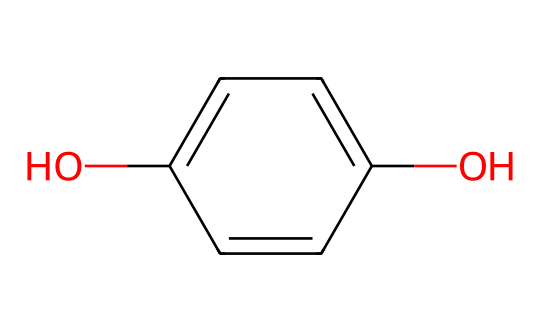What is the name of this chemical? The SMILES representation corresponds to the structure of hydroquinone, which is a dihydroxybenzene derivative known for its use in skin-lightening products.
Answer: hydroquinone How many hydroxyl (–OH) groups are present in this molecule? The structure has two hydroxyl groups (–OH) attached to the benzene ring, indicated by the two 'O' atoms in the SMILES representation.
Answer: 2 What is the type of functional groups in this compound? The compound contains phenolic hydroxyl groups, which are characteristic of phenols, indicated by the presence of the –OH groups attached to the aromatic ring.
Answer: phenolic How many carbon atoms are in this molecule? The benzene ring consists of six carbon atoms, and there are two additional carbon atoms from the two hydroxyl groups, totaling eight carbon atoms in the structure.
Answer: 6 What is the overall charge of this molecule? The SMILES structure does not indicate any ionic charges; hence, the overall charge of hydroquinone is neutral.
Answer: neutral Why is hydroquinone used in skin-lightening products? Hydroquinone inhibits melanin production due to its phenolic structure, which allows it to interfere with the enzymatic activity linked to melanin formation.
Answer: inhibits melanin production What type of reaction might involve hydroquinone in skincare formulations? Hydroquinone often participates in reduction reactions where it acts as a reducing agent to lighten skin pigmentation by affecting the melanin biosynthesis pathway.
Answer: reduction reaction 